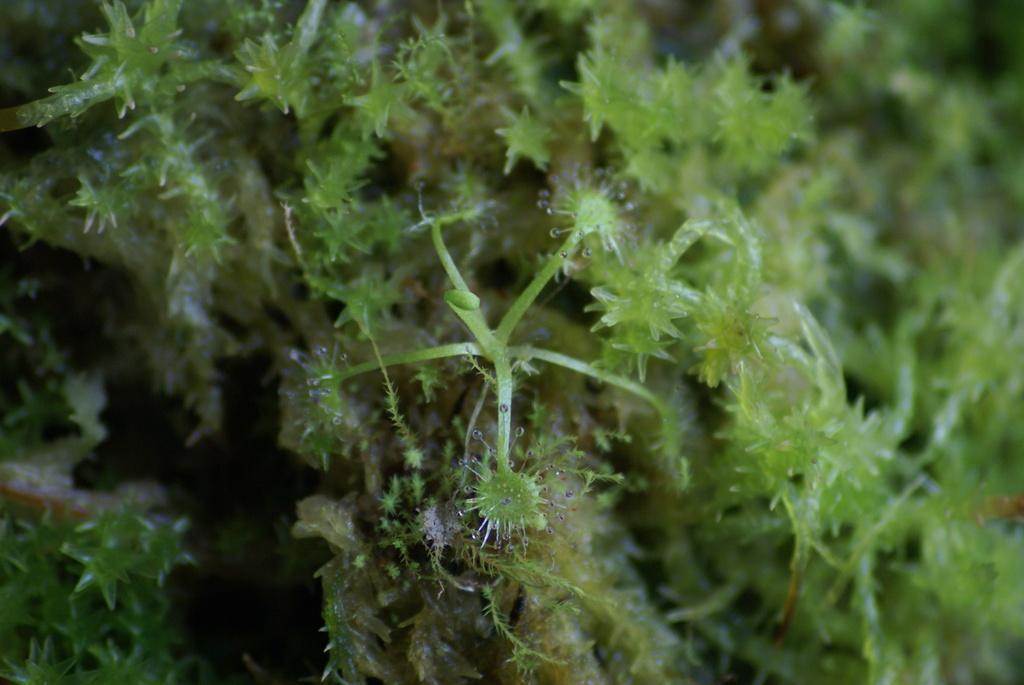Please provide a concise description of this image. In this image we can see the liverworts. 